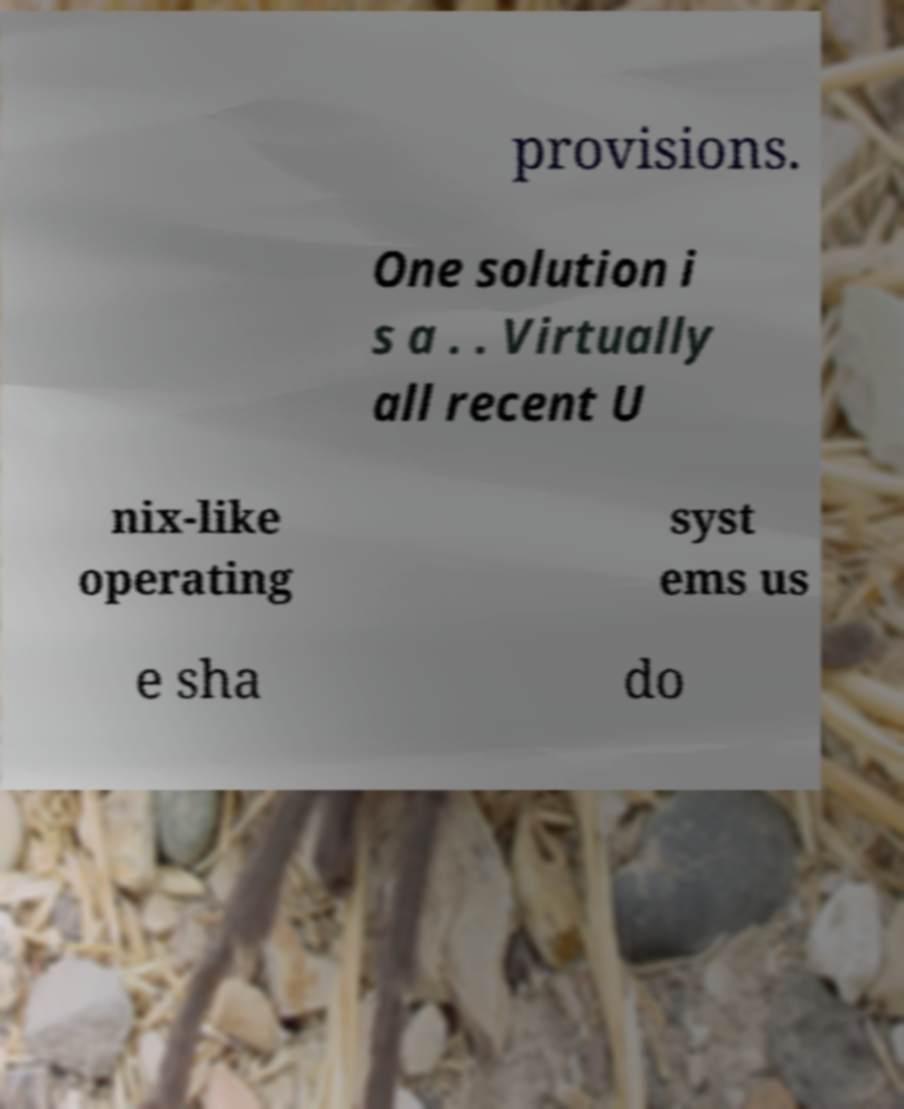Can you accurately transcribe the text from the provided image for me? provisions. One solution i s a . . Virtually all recent U nix-like operating syst ems us e sha do 